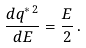<formula> <loc_0><loc_0><loc_500><loc_500>\frac { d q ^ { \ast \, 2 } } { d E } = \frac { E } { 2 } \, .</formula> 